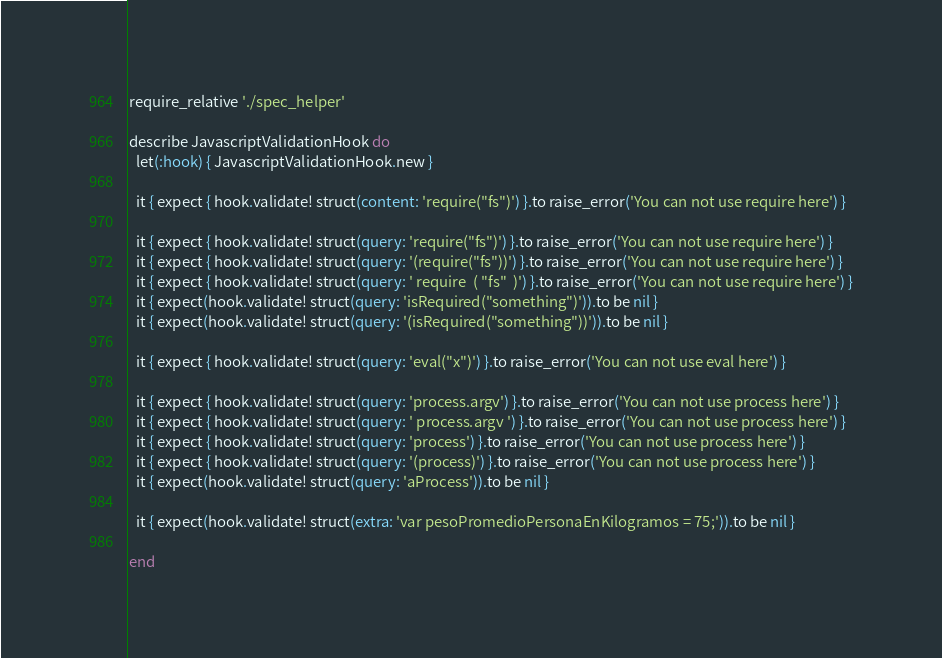<code> <loc_0><loc_0><loc_500><loc_500><_Ruby_>require_relative './spec_helper'

describe JavascriptValidationHook do
  let(:hook) { JavascriptValidationHook.new }

  it { expect { hook.validate! struct(content: 'require("fs")') }.to raise_error('You can not use require here') }

  it { expect { hook.validate! struct(query: 'require("fs")') }.to raise_error('You can not use require here') }
  it { expect { hook.validate! struct(query: '(require("fs"))') }.to raise_error('You can not use require here') }
  it { expect { hook.validate! struct(query: ' require  ( "fs"  )') }.to raise_error('You can not use require here') }
  it { expect(hook.validate! struct(query: 'isRequired("something")')).to be nil }
  it { expect(hook.validate! struct(query: '(isRequired("something"))')).to be nil }

  it { expect { hook.validate! struct(query: 'eval("x")') }.to raise_error('You can not use eval here') }

  it { expect { hook.validate! struct(query: 'process.argv') }.to raise_error('You can not use process here') }
  it { expect { hook.validate! struct(query: ' process.argv ') }.to raise_error('You can not use process here') }
  it { expect { hook.validate! struct(query: 'process') }.to raise_error('You can not use process here') }
  it { expect { hook.validate! struct(query: '(process)') }.to raise_error('You can not use process here') }
  it { expect(hook.validate! struct(query: 'aProcess')).to be nil }

  it { expect(hook.validate! struct(extra: 'var pesoPromedioPersonaEnKilogramos = 75;')).to be nil }

end
</code> 